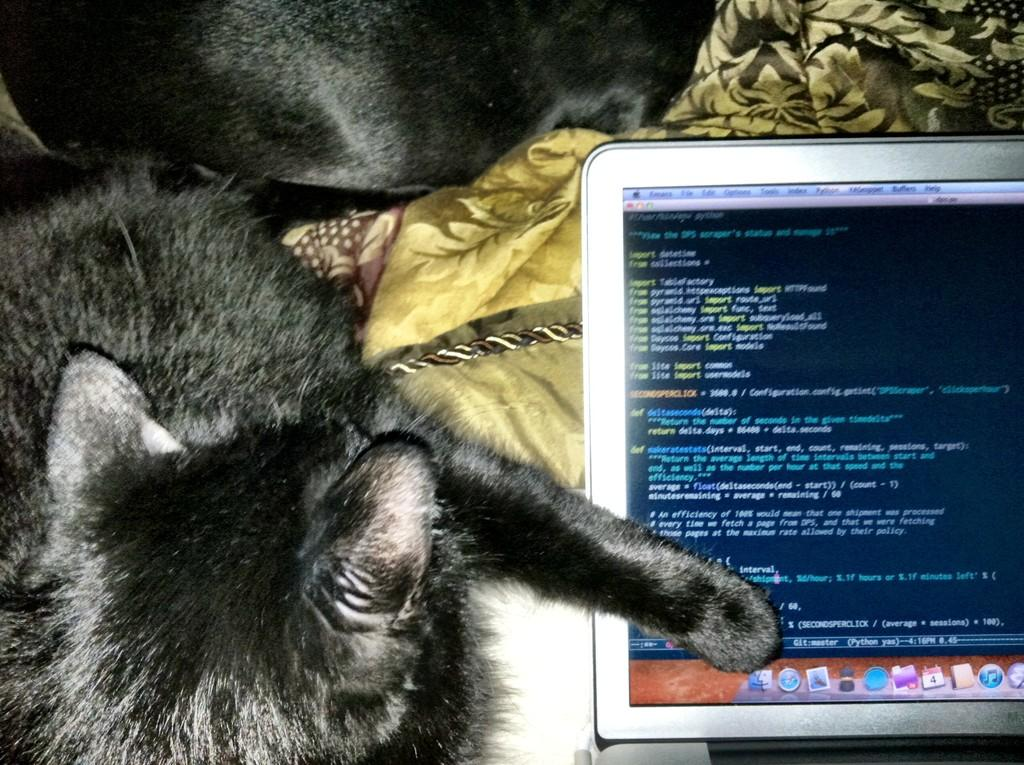How many pets can be seen in the image? There are two pets in the image. What is the color of the pets? The pets are black in color. What electronic device is located on the right side of the image? There is a laptop on the right side of the image. What type of furniture is present in the image? There is a bed in the image. What is covering the bed? There are bed sheets on the bed. What type of tank is visible in the image? There is no tank present in the image. How many wheels can be seen on the pets in the image? Pets do not have wheels, so this question cannot be answered. 